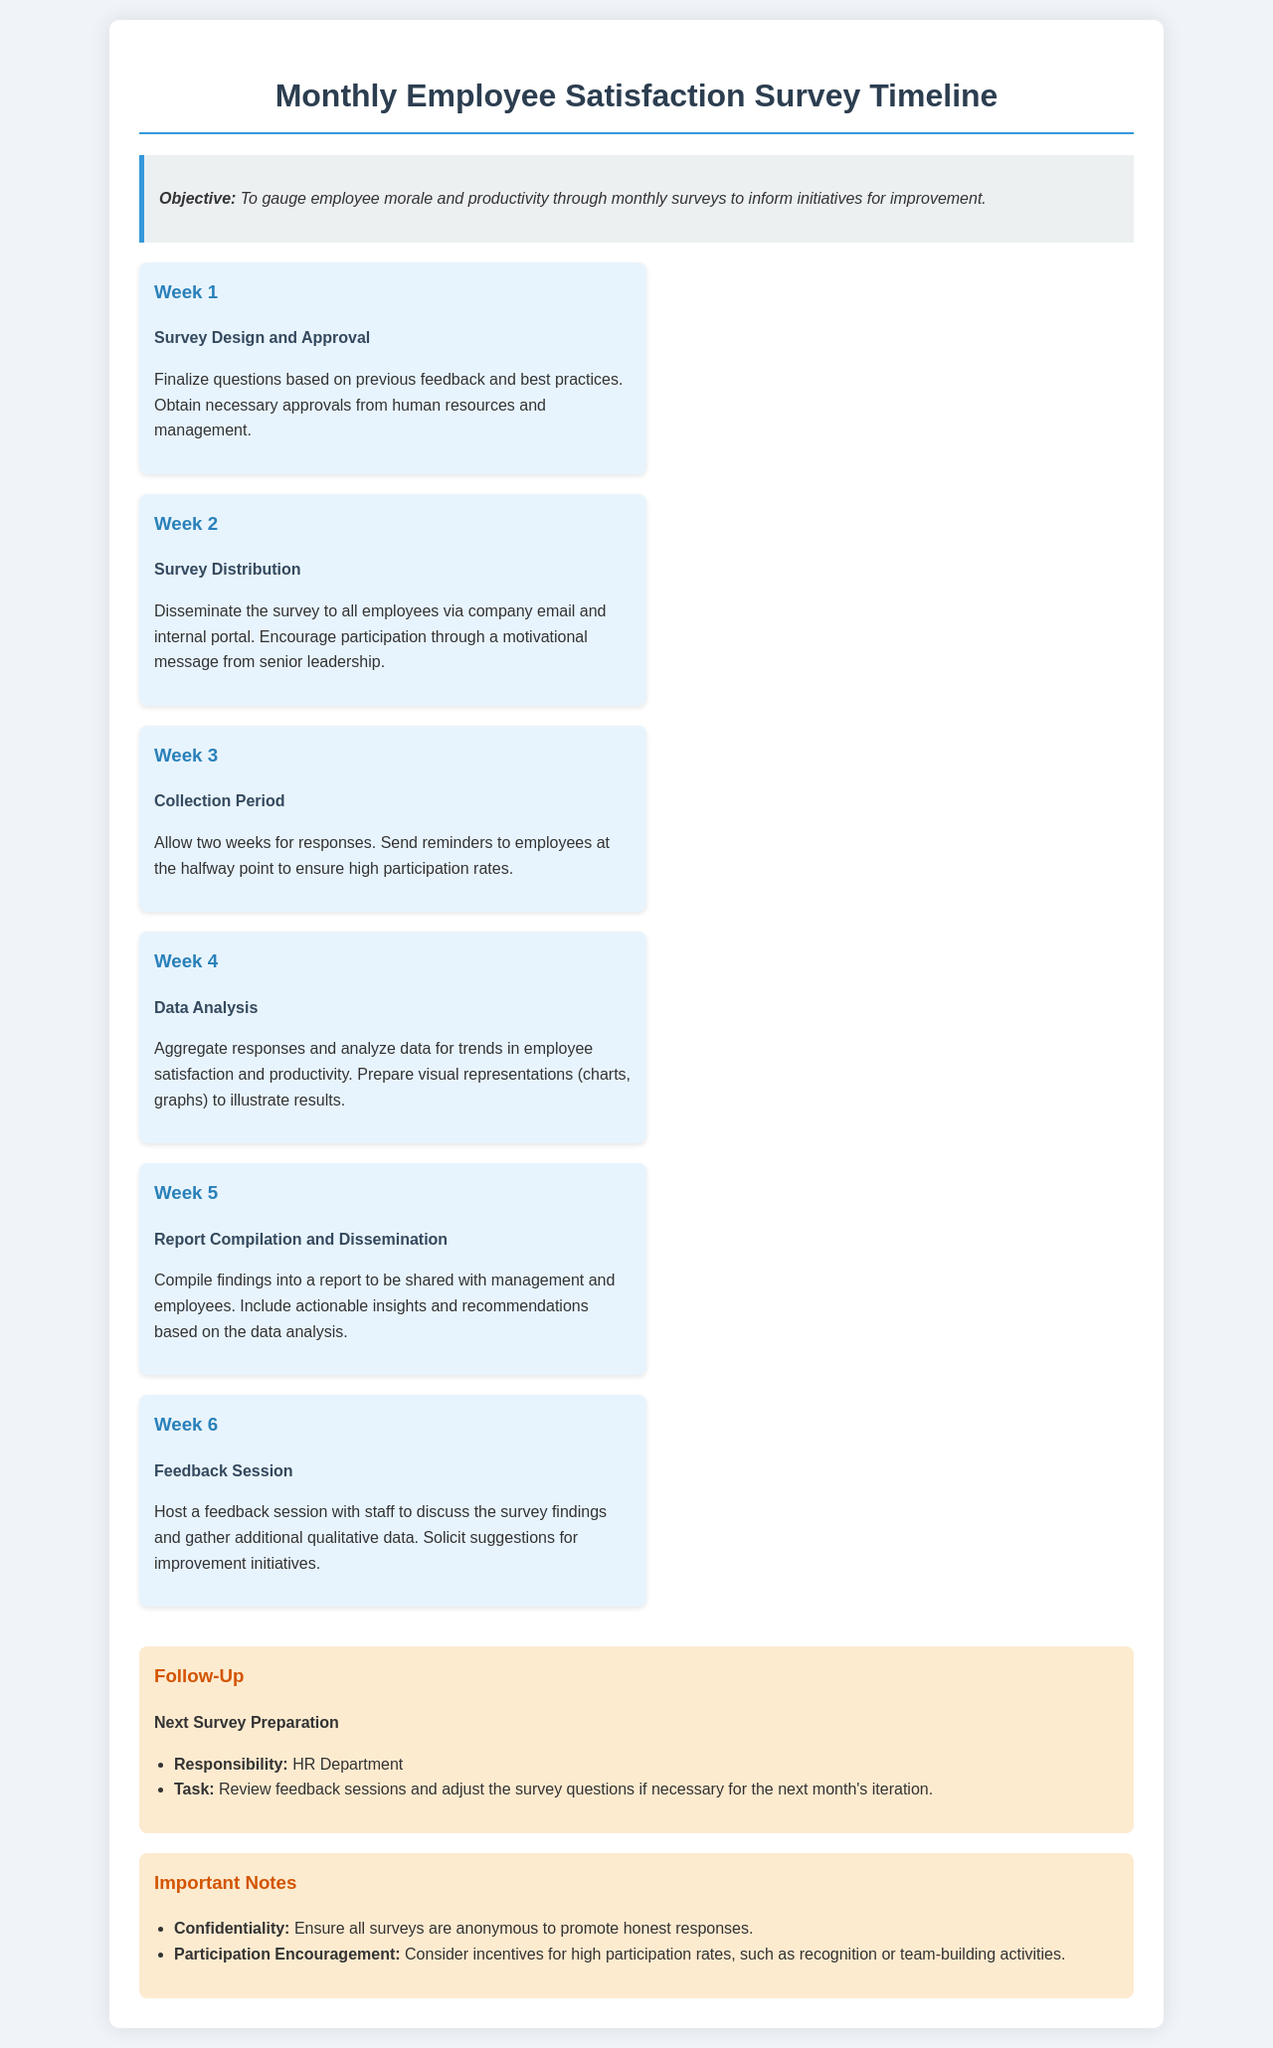What is the objective of the survey? The objective is stated in the document and focuses on gauging employee morale and productivity to inform initiatives for improvement.
Answer: To gauge employee morale and productivity In which week does the survey distribution occur? The document outlines the tasks for each week and specifies the survey distribution in Week 2.
Answer: Week 2 How long is the collection period for responses? The collection period is mentioned as allowing two weeks for responses.
Answer: Two weeks Which department is responsible for the next survey preparation? The document states that the HR Department is responsible for the next survey preparation under the Follow-Up section.
Answer: HR Department What important consideration is highlighted regarding survey responses? The document emphasizes confidentiality to ensure honest responses, which is an important aspect of the survey process.
Answer: Confidentiality What task is performed during Week 4? The task detailed for Week 4 involves data analysis of the collected responses.
Answer: Data Analysis What is recommended to encourage high participation rates? The document suggests considering incentives such as recognition or team-building activities to encourage participation.
Answer: Incentives In which week is the feedback session hosted? The feedback session is scheduled for Week 6, as outlined in the timeline.
Answer: Week 6 What is included in the report compiled in Week 5? The report compiled in Week 5 includes findings, actionable insights, and recommendations based on data analysis.
Answer: Findings and recommendations 